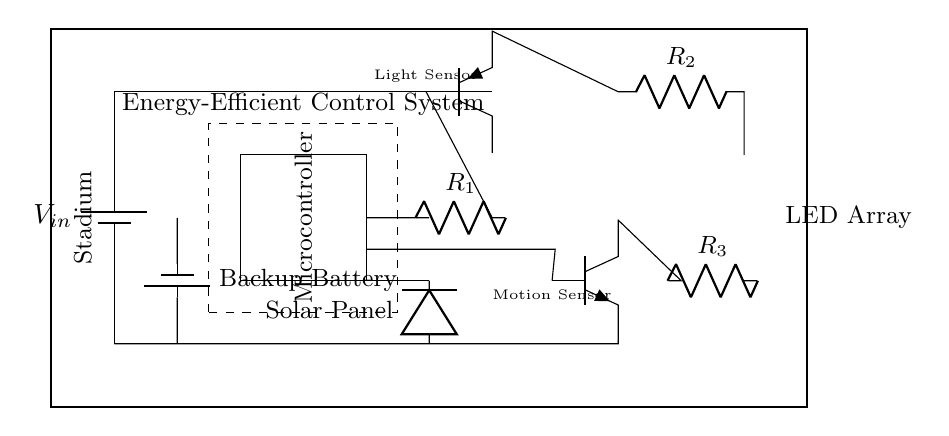What type of sensors are included in this circuit? The circuit includes a light sensor and a motion sensor which are indicated by the labels near the components. The light sensor is depicted as a PNP transistor and the motion sensor as an NPN transistor.
Answer: Light and motion What is the main power source for this circuit? The circuit utilizes a backup battery as well as a solar panel, which is noted in the circuit. The solar panel is explicitly pointed out as the primary energy-efficient component providing power.
Answer: Solar panel How many LEDs are in the LED array? The LED array in the circuit consists of three individual LEDs indicated by the three LED symbols positioned vertically near the right side of the circuit.
Answer: Three What is the role of the microcontroller in this circuit? The microcontroller, which is placed in the center of the circuit, operates as the control unit for the lighting system, processing inputs from the sensors to manage the LEDs accordingly.
Answer: Control unit Which components are responsible for energy efficiency in the circuit? Energy efficiency is achieved through the inclusion of a solar panel for power generation and a backup battery for energy storage, as indicated in the circuit layout.
Answer: Solar panel and backup battery How are the sensors connected to the microcontroller? The light sensor is connected directly to the microcontroller through resistor connections, while the motion sensor also connects via series wires, emphasizing the circuit's logic flow management from sensors to control unit.
Answer: Resistors 